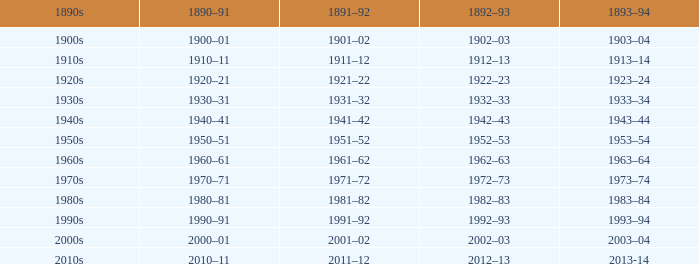In the range of 1892-93, which year is part of the 1890s to 1940s era? 1942–43. 